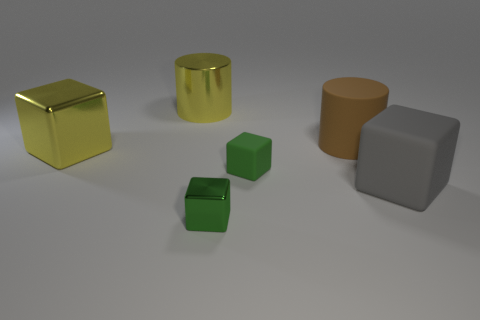Are the tiny thing to the left of the green rubber thing and the gray thing made of the same material?
Give a very brief answer. No. Is there a rubber cylinder that has the same size as the green metallic cube?
Give a very brief answer. No. There is a large brown rubber object; is its shape the same as the small thing that is to the left of the green rubber object?
Offer a very short reply. No. There is a big cylinder left of the object in front of the gray object; are there any large yellow objects that are on the left side of it?
Keep it short and to the point. Yes. The rubber cylinder has what size?
Your response must be concise. Large. How many other things are the same color as the metal cylinder?
Ensure brevity in your answer.  1. There is a large object that is in front of the large shiny cube; is it the same shape as the big brown object?
Your response must be concise. No. What is the color of the other shiny object that is the same shape as the brown object?
Ensure brevity in your answer.  Yellow. Is there anything else that has the same material as the brown object?
Your answer should be compact. Yes. There is a yellow metal thing that is the same shape as the large brown rubber object; what is its size?
Provide a succinct answer. Large. 